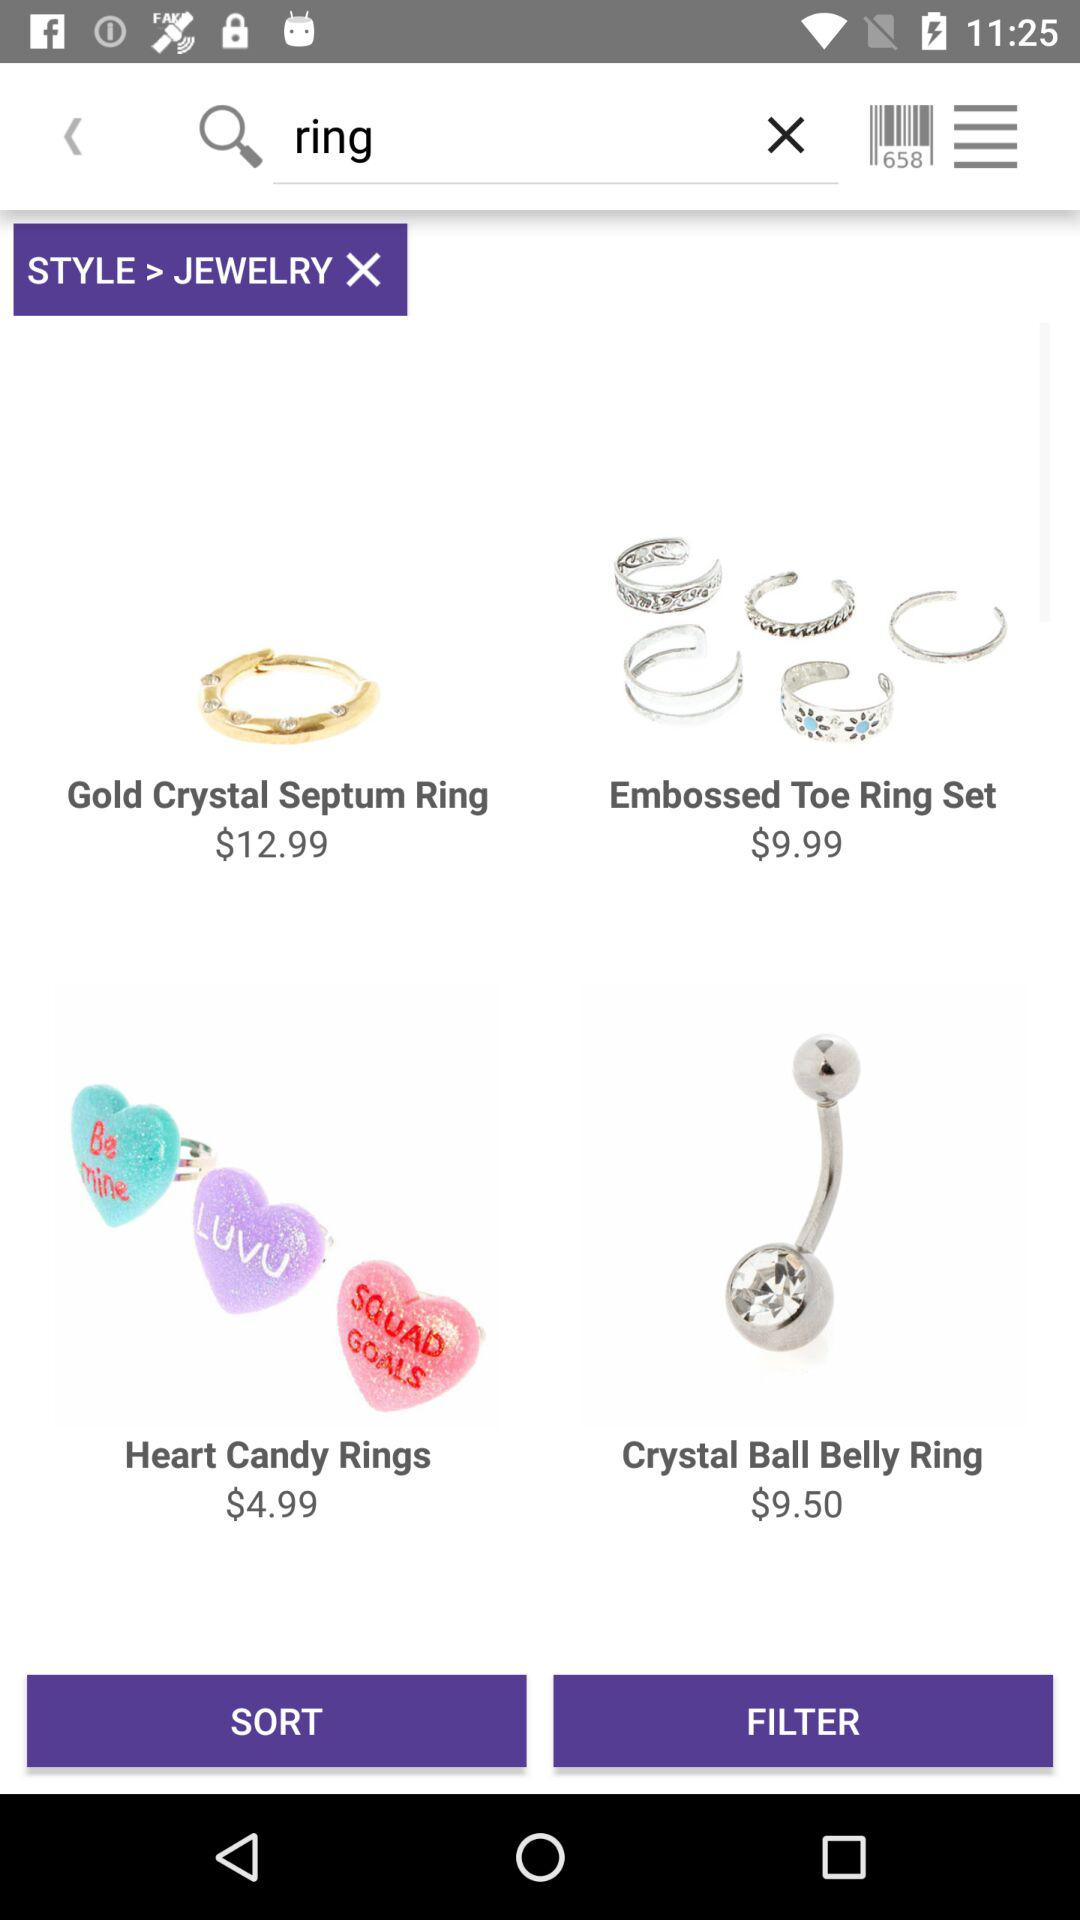What is the price of the "Gold Crystal Septum Ring"? The price of the "Gold Crystal Septum Ring" is $12.99. 